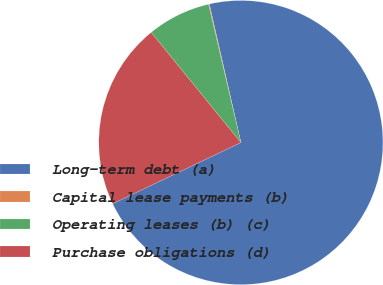Convert chart to OTSL. <chart><loc_0><loc_0><loc_500><loc_500><pie_chart><fcel>Long-term debt (a)<fcel>Capital lease payments (b)<fcel>Operating leases (b) (c)<fcel>Purchase obligations (d)<nl><fcel>71.48%<fcel>0.09%<fcel>7.22%<fcel>21.21%<nl></chart> 